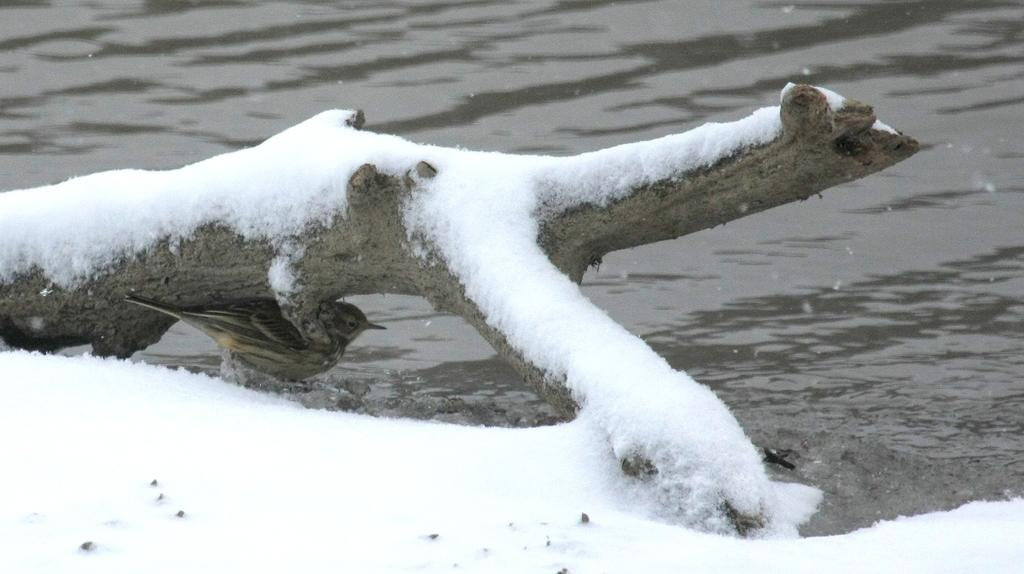What type of weather is depicted in the image? There is snow at the bottom of the image, indicating cold weather. Where is the bird located in the image? The bird is under a trunk in the image. What is the condition of the trunk in the image? The trunk has snow on it. What can be seen at the top of the image? There is water visible at the top of the image. What scientific theory is being tested in the image? There is no indication of a scientific theory being tested in the image. 